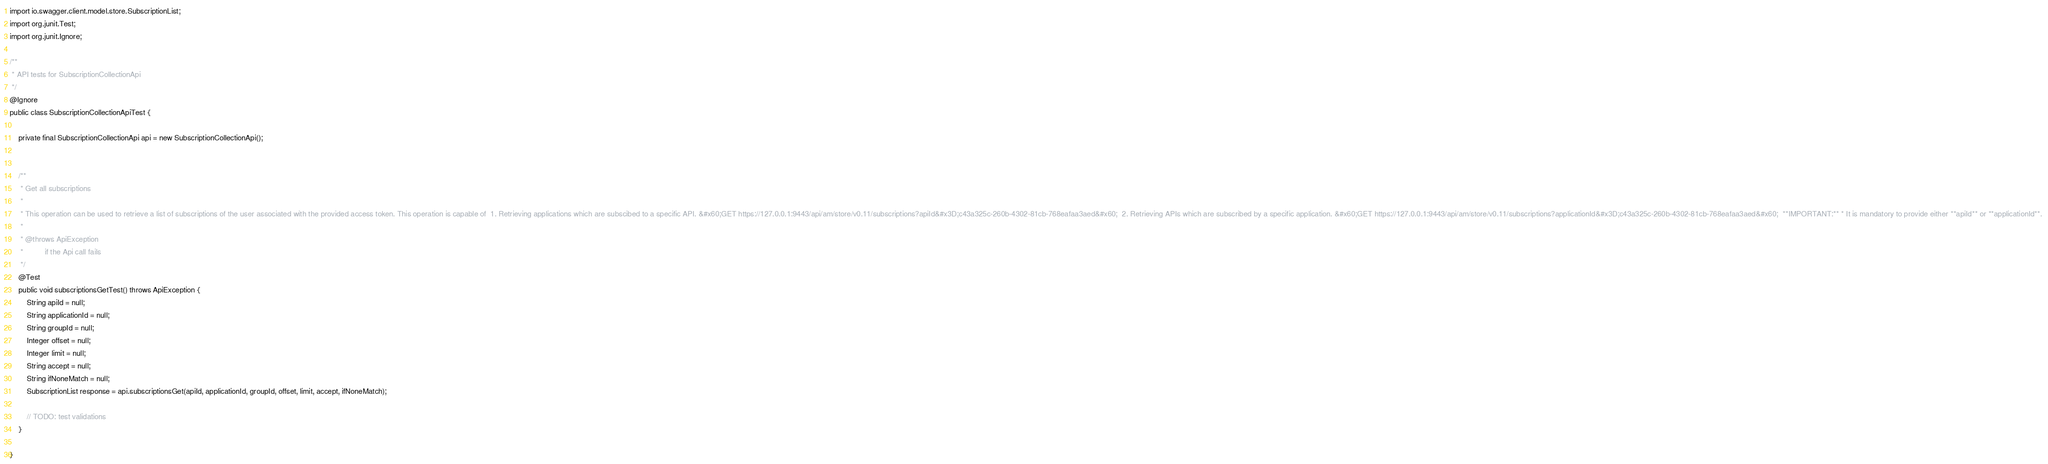Convert code to text. <code><loc_0><loc_0><loc_500><loc_500><_Java_>import io.swagger.client.model.store.SubscriptionList;
import org.junit.Test;
import org.junit.Ignore;

/**
 * API tests for SubscriptionCollectionApi
 */
@Ignore
public class SubscriptionCollectionApiTest {

    private final SubscriptionCollectionApi api = new SubscriptionCollectionApi();

    
    /**
     * Get all subscriptions 
     *
     * This operation can be used to retrieve a list of subscriptions of the user associated with the provided access token. This operation is capable of  1. Retrieving applications which are subscibed to a specific API. &#x60;GET https://127.0.0.1:9443/api/am/store/v0.11/subscriptions?apiId&#x3D;c43a325c-260b-4302-81cb-768eafaa3aed&#x60;  2. Retrieving APIs which are subscribed by a specific application. &#x60;GET https://127.0.0.1:9443/api/am/store/v0.11/subscriptions?applicationId&#x3D;c43a325c-260b-4302-81cb-768eafaa3aed&#x60;  **IMPORTANT:** * It is mandatory to provide either **apiId** or **applicationId**. 
     *
     * @throws ApiException
     *          if the Api call fails
     */
    @Test
    public void subscriptionsGetTest() throws ApiException {
        String apiId = null;
        String applicationId = null;
        String groupId = null;
        Integer offset = null;
        Integer limit = null;
        String accept = null;
        String ifNoneMatch = null;
        SubscriptionList response = api.subscriptionsGet(apiId, applicationId, groupId, offset, limit, accept, ifNoneMatch);

        // TODO: test validations
    }
    
}
</code> 